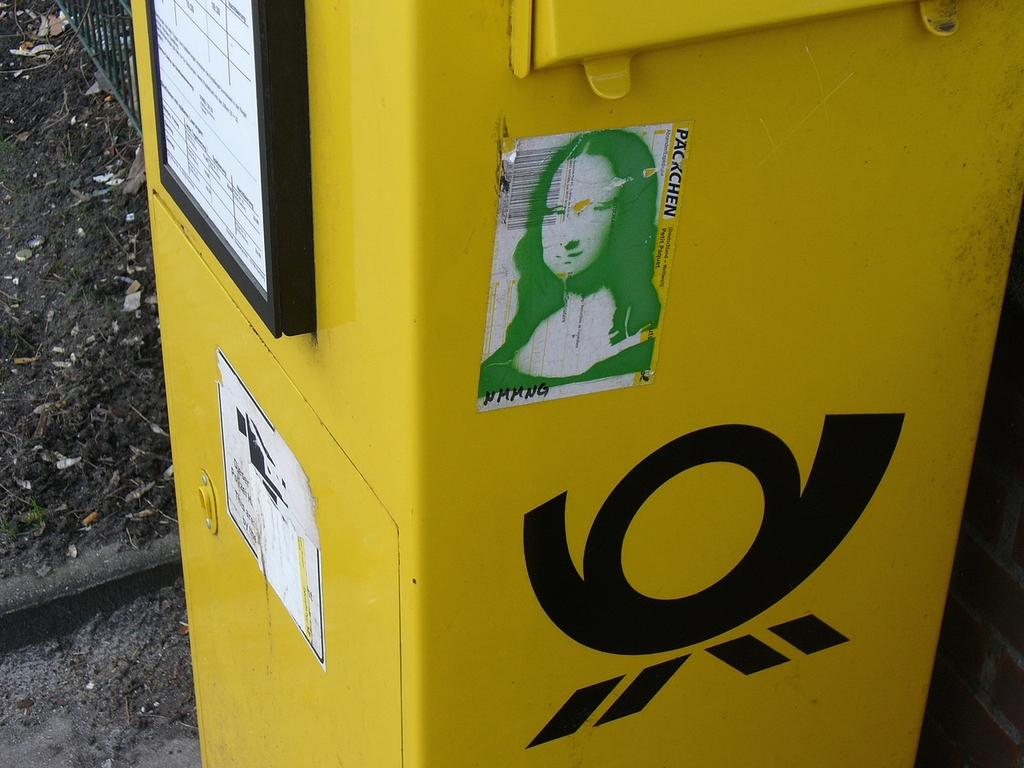<image>
Relay a brief, clear account of the picture shown. A sticker on a yellow box with the words packchen. 